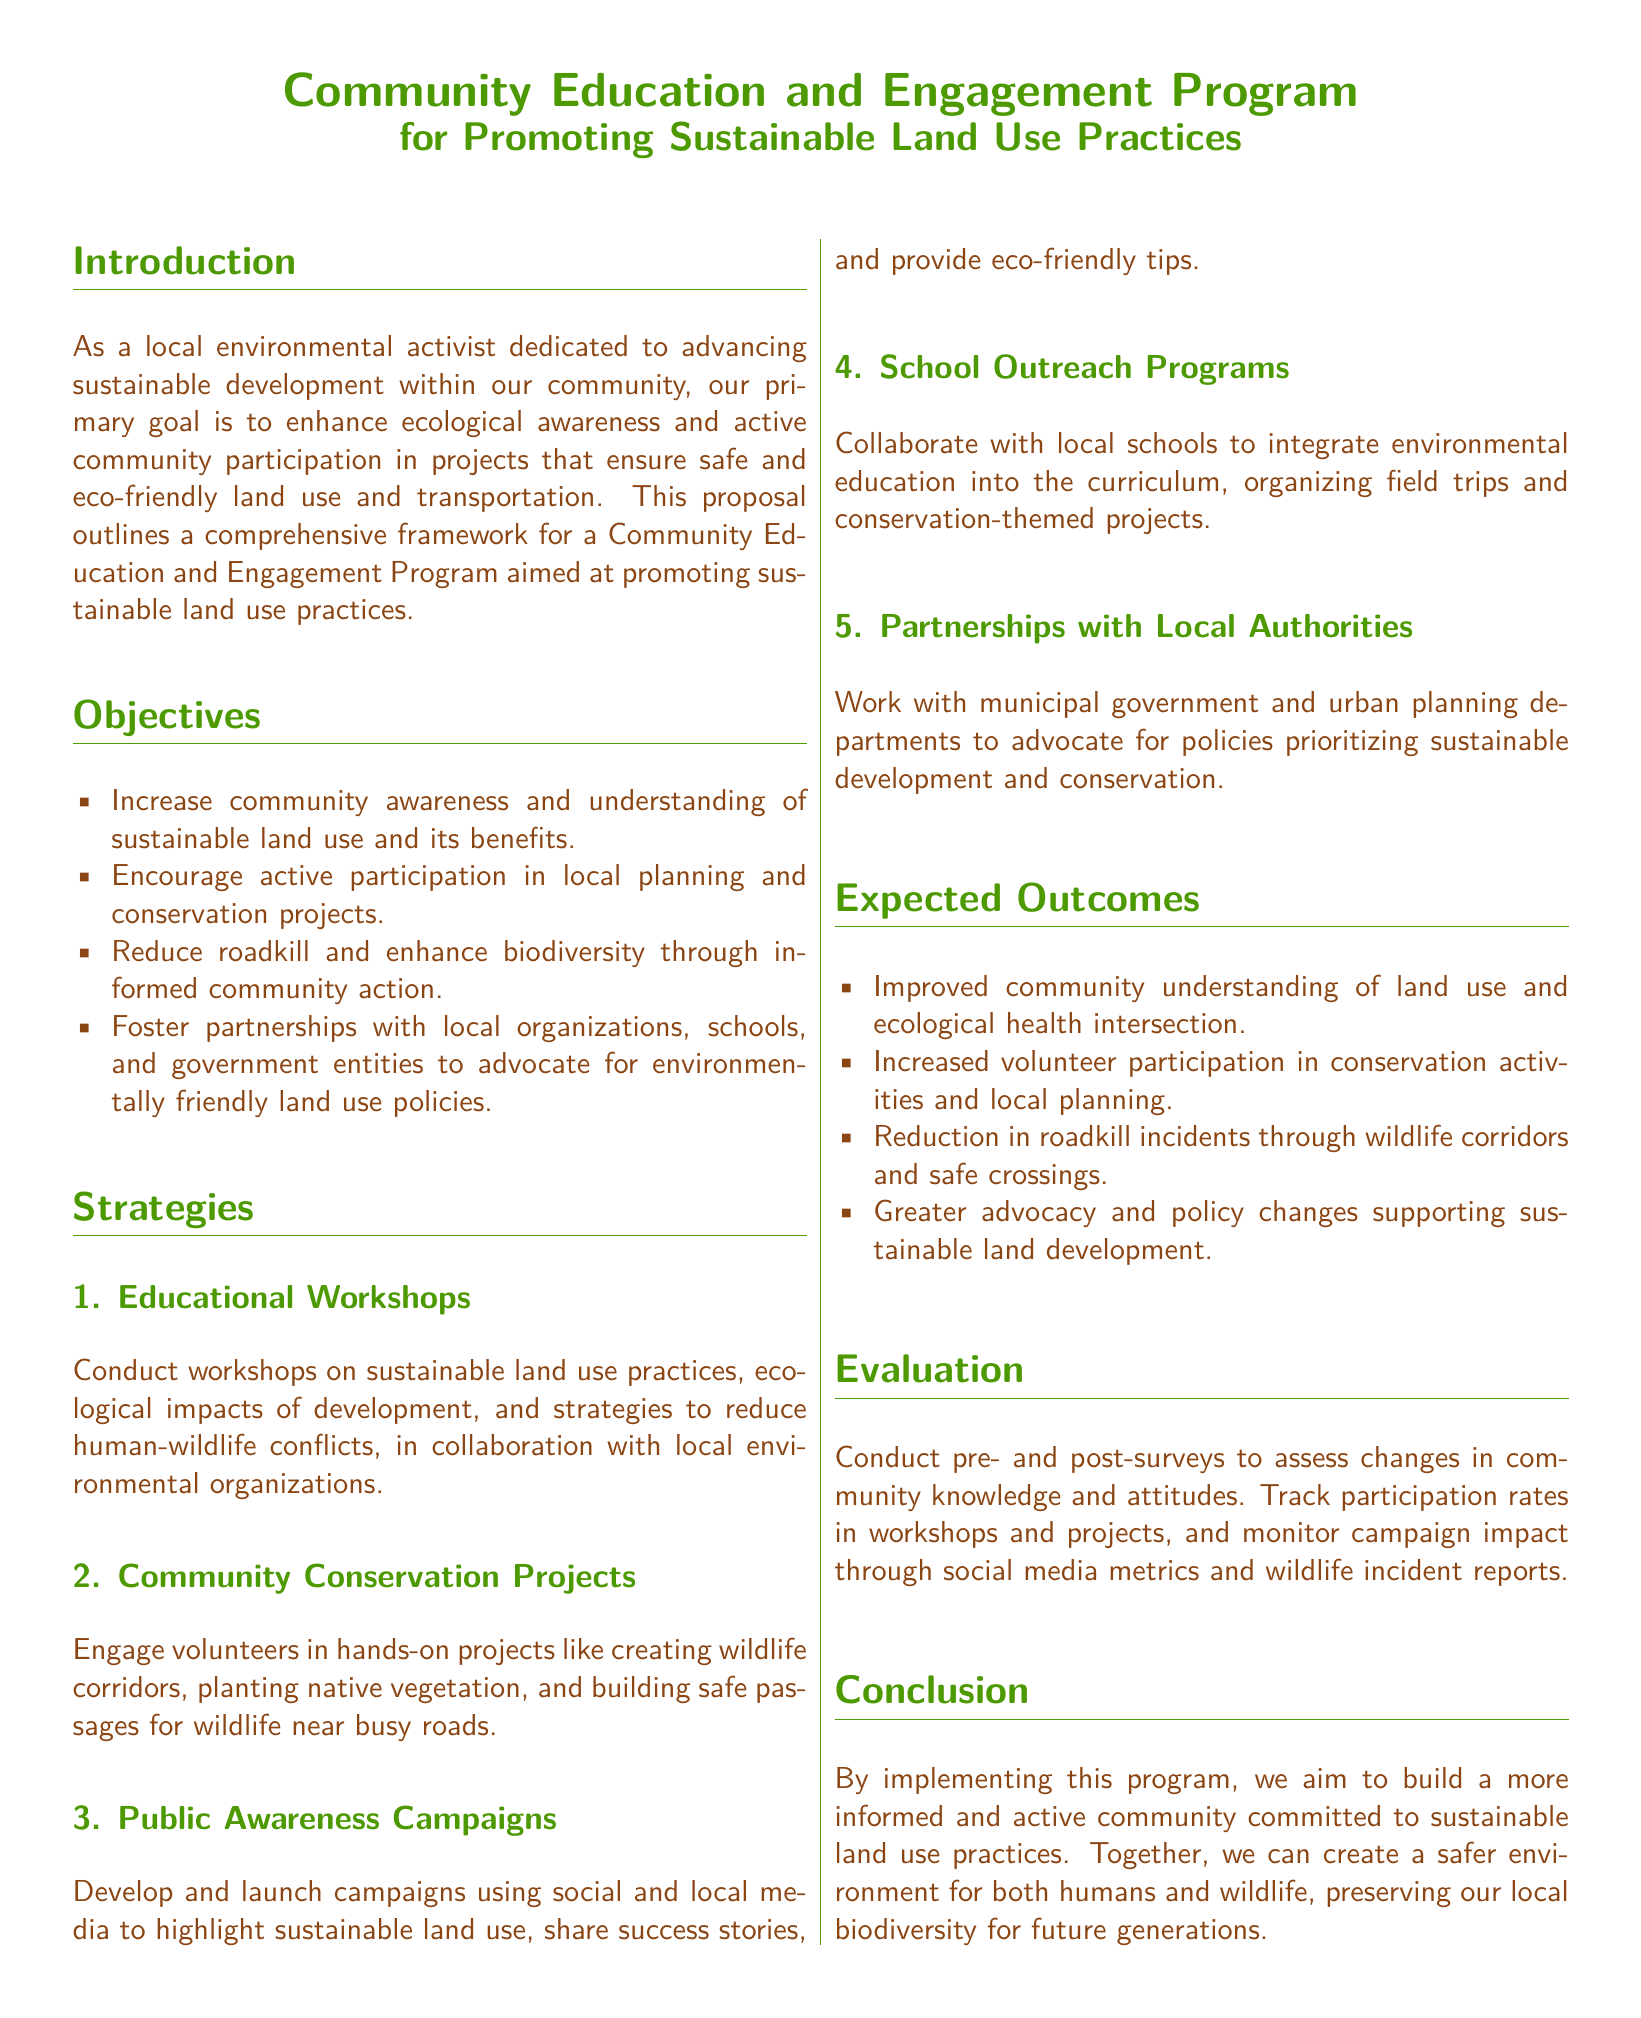what is the primary goal of the program? The primary goal is to enhance ecological awareness and active community participation in projects that ensure safe and eco-friendly land use and transportation.
Answer: enhance ecological awareness how many strategies are outlined in the proposal? The document lists a total of five strategies to promote sustainable land use practices.
Answer: five what is one expected outcome of the program? The expected outcomes include improved community understanding of land use and ecological health intersection.
Answer: improved community understanding which type of projects will involve volunteer engagement? The program includes hands-on projects like creating wildlife corridors and planting native vegetation that engage volunteers.
Answer: Community Conservation Projects what method will be used to evaluate the program's effectiveness? Pre- and post-surveys will be conducted to assess changes in community knowledge and attitudes.
Answer: pre- and post-surveys who will the program collaborate with to integrate environmental education? The program will collaborate with local schools to integrate environmental education into the curriculum.
Answer: local schools how many objectives are there in the proposal? The document outlines a total of four objectives aimed at promoting sustainable land use practices.
Answer: four what color represents the title headings in the document? The title headings are represented in leaf green color as specified in the document formatting.
Answer: leaf green 